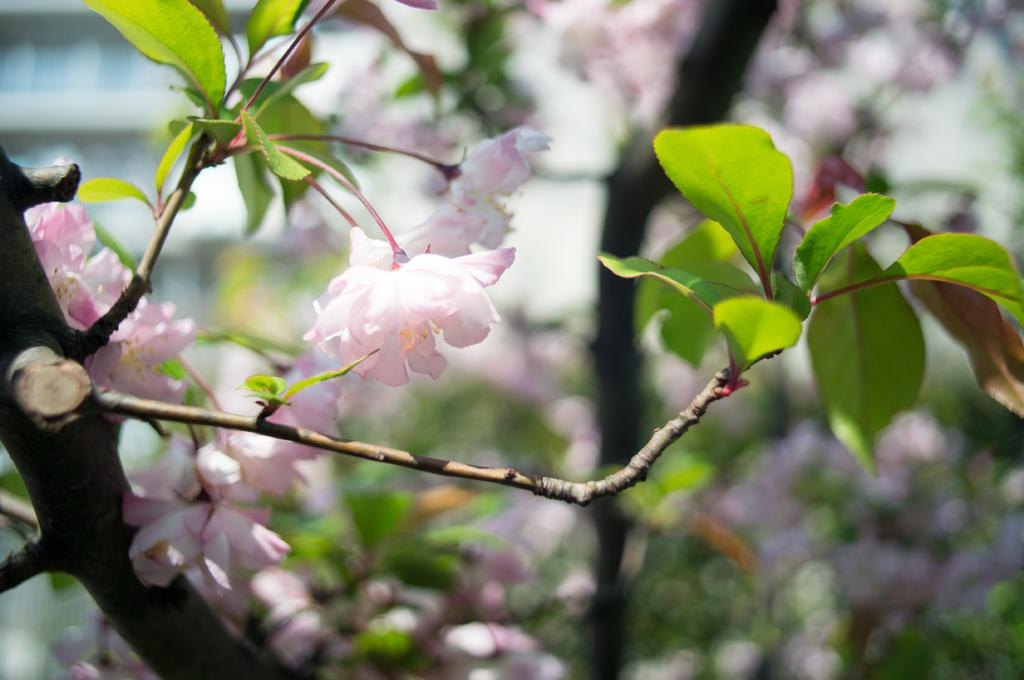What is the main subject of the image? The main subject of the image is a tree. What can be observed about the tree's appearance? The tree has pink color flowers. Can you describe the background of the image? The background of the image is blurred. What type of locket can be seen hanging from the tree in the image? There is no locket present in the image; it features a tree with pink flowers and a blurred background. 